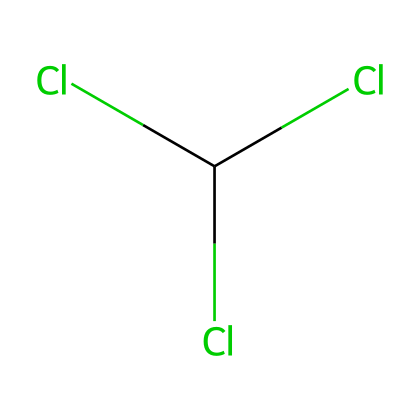What is the chemical name of this solvent? The SMILES representation indicates that the molecule contains one carbon (C) atom, three chlorine (Cl) atoms, and it is recognized as chloroform, which is a common name for this compound.
Answer: chloroform How many chlorine atoms are present in this structure? Looking at the SMILES representation, there are three chlorine (Cl) symbols, indicating that there are three chlorine atoms in this molecule.
Answer: three What type of bonds are found between the carbon and chlorine atoms? The carbon atom in chloroform has single bonds with each of the three chlorine atoms. Each C-Cl bond is represented in the SMILES without any numerical indication, suggesting they are single covalent bonds.
Answer: single What is the total number of atoms in this chemical? The structure consists of one carbon atom (C) and three chlorine atoms (Cl), leading to a total count of four atoms in the entire molecule.
Answer: four Why might chloroform have been used as an anesthetic? Chloroform's chemical structure allows it to easily dissolve in lipids, enabling it to affect the nervous system rapidly when inhaled, which is why it was historically used as an anesthetic.
Answer: lipid-soluble Is chloroform polar or nonpolar? Chloroform has a molecular structure that features a larger number of chlorine atoms, which are electronegative, making the molecule overall polar due to the asymmetry in charge distribution despite the presence of the central carbon atom.
Answer: polar 